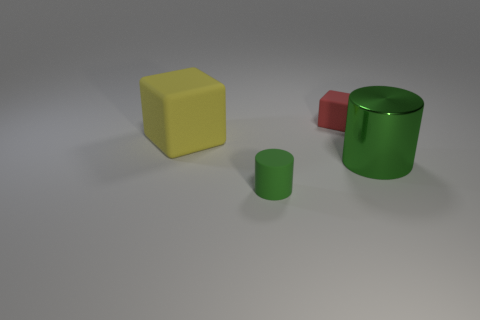There is a tiny object in front of the big yellow object; what shape is it?
Keep it short and to the point. Cylinder. How many tiny things have the same shape as the big green metal thing?
Keep it short and to the point. 1. What is the size of the matte object in front of the yellow thing that is on the left side of the green rubber thing?
Provide a short and direct response. Small. What number of purple objects are tiny rubber blocks or large rubber blocks?
Provide a short and direct response. 0. Is the number of yellow objects on the right side of the small cube less than the number of yellow matte things that are right of the tiny green cylinder?
Provide a short and direct response. No. There is a green metal object; is it the same size as the matte cube that is in front of the red rubber block?
Your answer should be very brief. Yes. How many shiny things have the same size as the green rubber object?
Keep it short and to the point. 0. How many small objects are either matte things or red things?
Offer a terse response. 2. Is there a yellow cube?
Keep it short and to the point. Yes. Is the number of matte blocks that are to the left of the yellow matte block greater than the number of green cylinders that are behind the red thing?
Your answer should be very brief. No. 